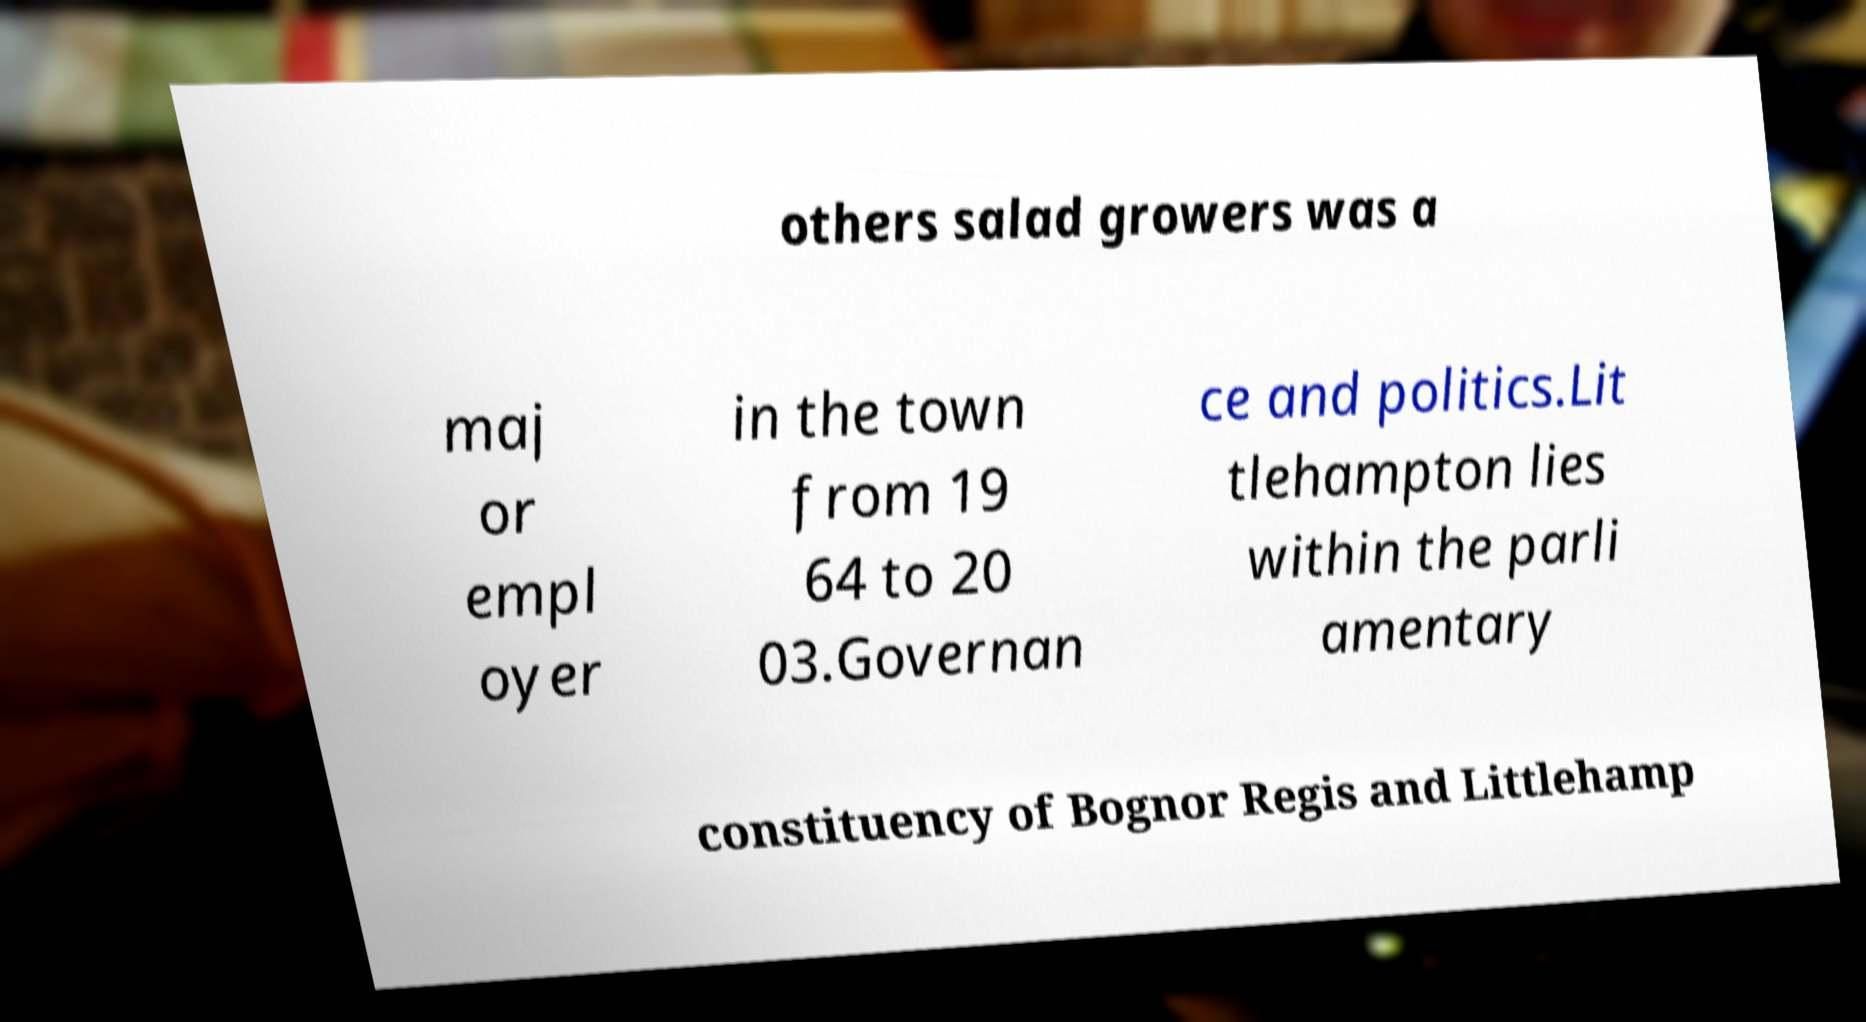Could you assist in decoding the text presented in this image and type it out clearly? others salad growers was a maj or empl oyer in the town from 19 64 to 20 03.Governan ce and politics.Lit tlehampton lies within the parli amentary constituency of Bognor Regis and Littlehamp 